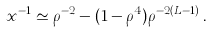Convert formula to latex. <formula><loc_0><loc_0><loc_500><loc_500>x ^ { - 1 } \simeq \rho ^ { - 2 } - ( 1 - \rho ^ { 4 } ) \rho ^ { - 2 ( L - 1 ) } \, .</formula> 